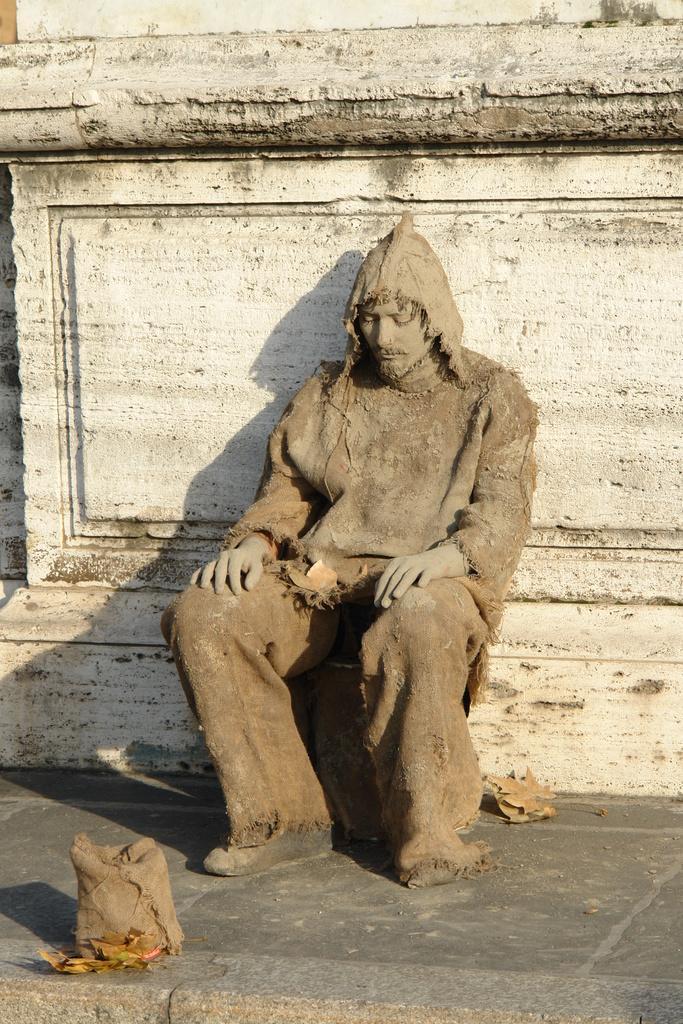How would you summarize this image in a sentence or two? Here we can see a man sitting. This is a wall. Here we can see dried leaves on the floor 